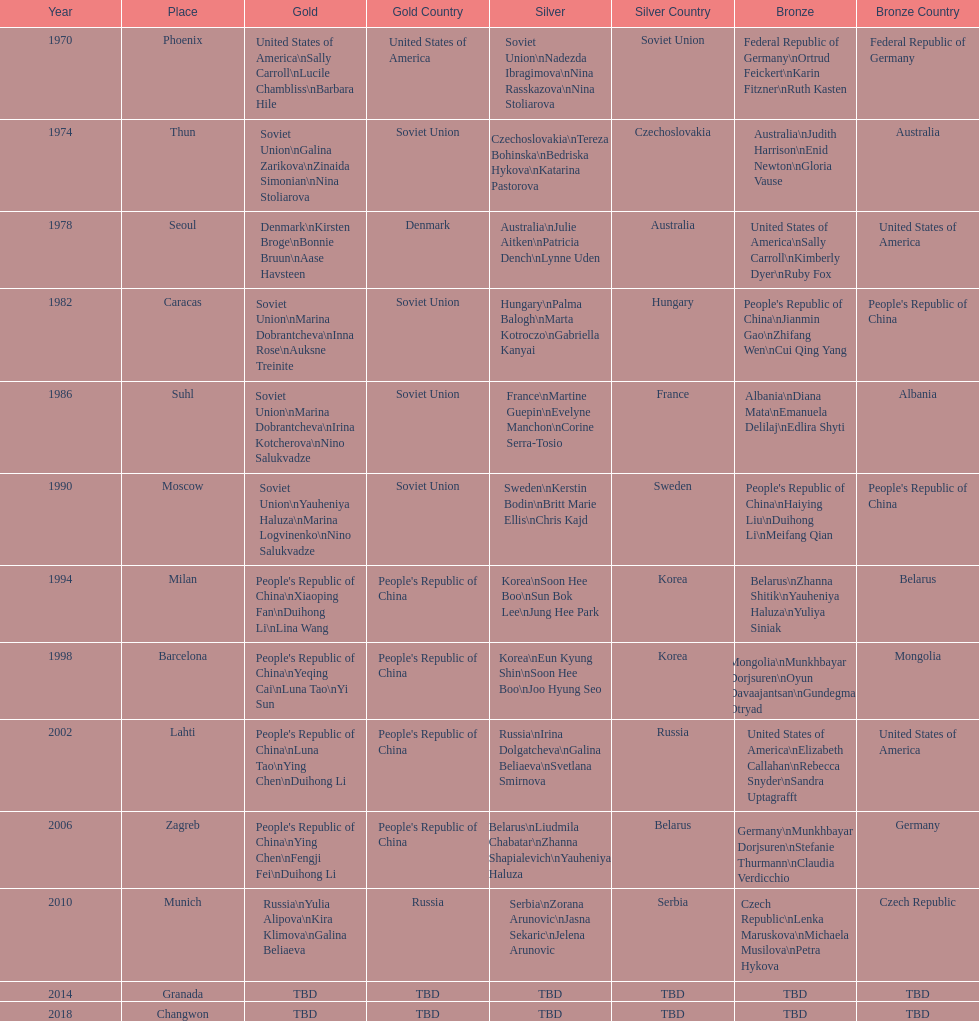Whose name is listed before bonnie bruun's in the gold column? Kirsten Broge. 